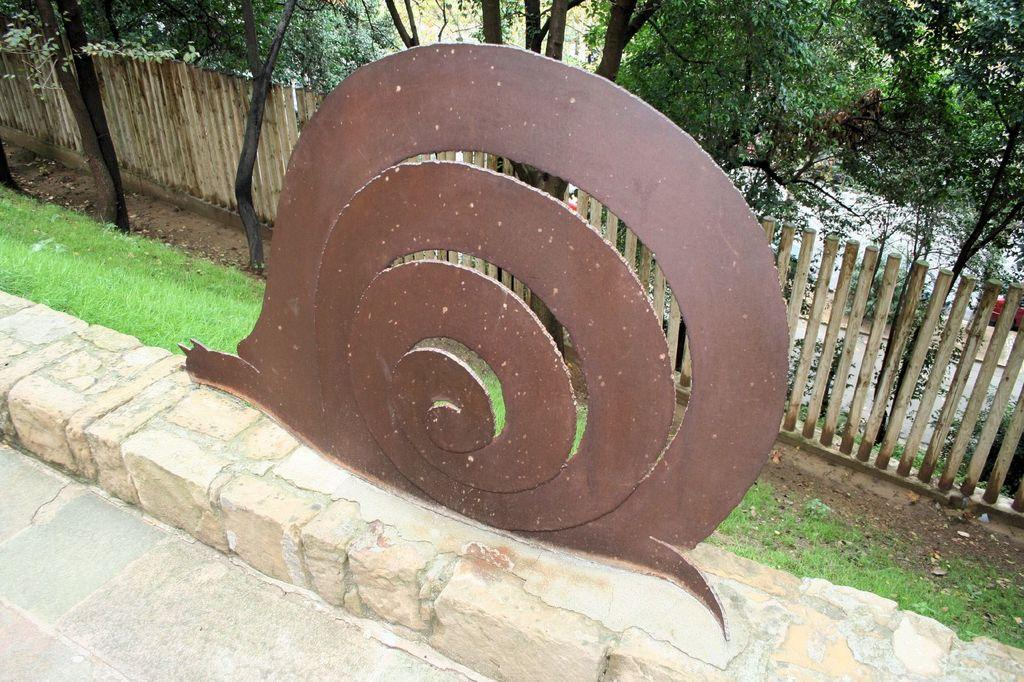What is the main subject in the center of the image? There is a model of a snail in the center of the image. What is located behind the snail model? There is a boundary behind the snail model. What can be seen in the background of the image? There are trees in the background of the image. How many sisters are present in the image? There are no sisters depicted in the image; it features a model of a snail with a boundary and trees in the background. 